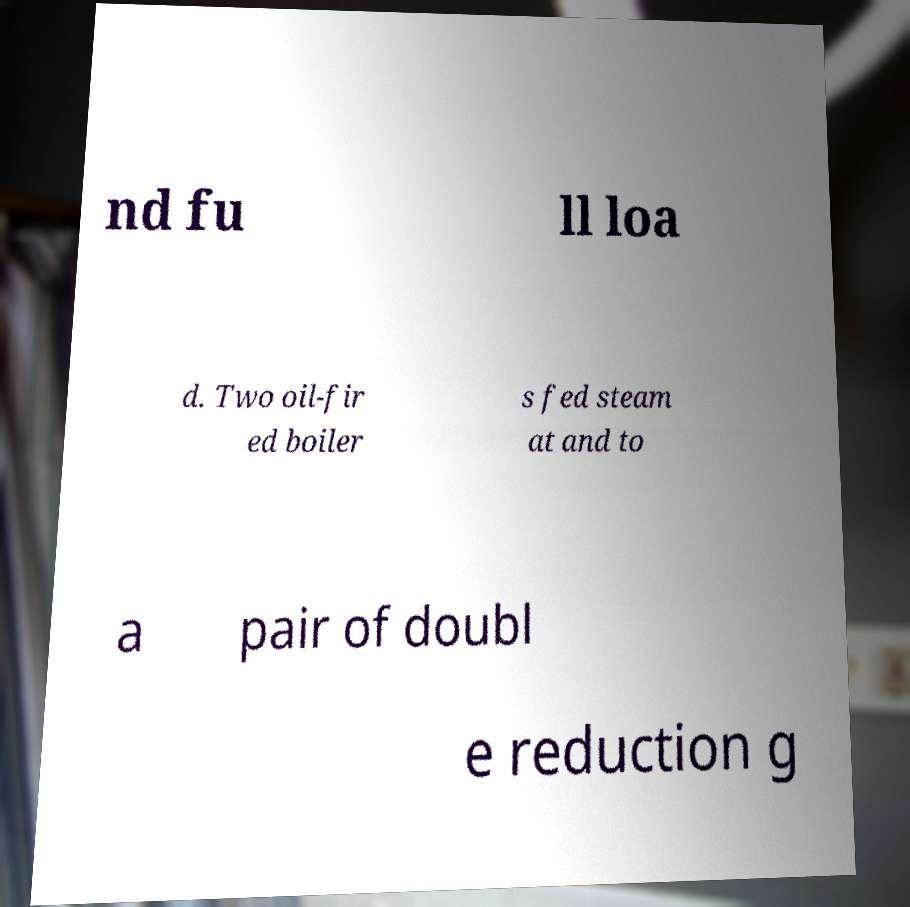Can you read and provide the text displayed in the image?This photo seems to have some interesting text. Can you extract and type it out for me? nd fu ll loa d. Two oil-fir ed boiler s fed steam at and to a pair of doubl e reduction g 